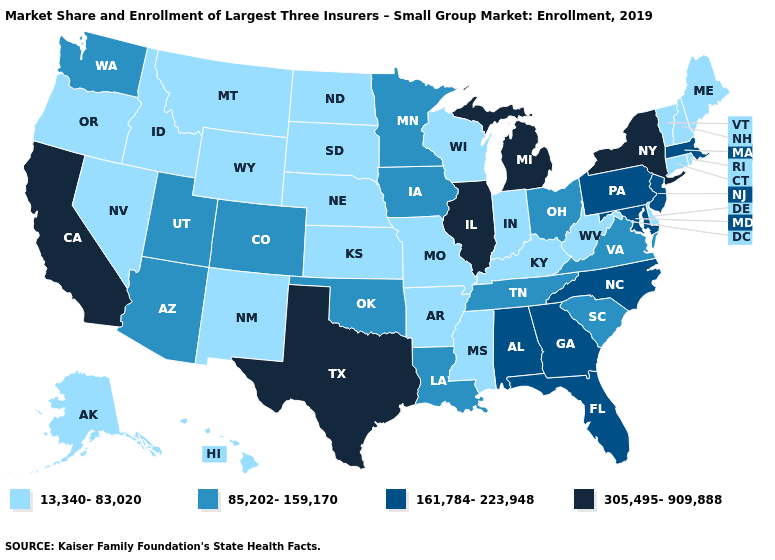What is the value of Louisiana?
Quick response, please. 85,202-159,170. Name the states that have a value in the range 161,784-223,948?
Keep it brief. Alabama, Florida, Georgia, Maryland, Massachusetts, New Jersey, North Carolina, Pennsylvania. What is the value of Pennsylvania?
Write a very short answer. 161,784-223,948. Name the states that have a value in the range 85,202-159,170?
Give a very brief answer. Arizona, Colorado, Iowa, Louisiana, Minnesota, Ohio, Oklahoma, South Carolina, Tennessee, Utah, Virginia, Washington. What is the value of Minnesota?
Quick response, please. 85,202-159,170. Does the map have missing data?
Answer briefly. No. Name the states that have a value in the range 85,202-159,170?
Quick response, please. Arizona, Colorado, Iowa, Louisiana, Minnesota, Ohio, Oklahoma, South Carolina, Tennessee, Utah, Virginia, Washington. What is the value of Oklahoma?
Be succinct. 85,202-159,170. Does California have the highest value in the West?
Concise answer only. Yes. What is the value of Montana?
Be succinct. 13,340-83,020. Name the states that have a value in the range 85,202-159,170?
Answer briefly. Arizona, Colorado, Iowa, Louisiana, Minnesota, Ohio, Oklahoma, South Carolina, Tennessee, Utah, Virginia, Washington. Among the states that border South Dakota , does Nebraska have the lowest value?
Be succinct. Yes. Name the states that have a value in the range 85,202-159,170?
Keep it brief. Arizona, Colorado, Iowa, Louisiana, Minnesota, Ohio, Oklahoma, South Carolina, Tennessee, Utah, Virginia, Washington. Does Ohio have a lower value than Indiana?
Give a very brief answer. No. What is the value of Idaho?
Quick response, please. 13,340-83,020. 